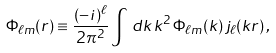<formula> <loc_0><loc_0><loc_500><loc_500>\Phi _ { \ell m } ( r ) \equiv \frac { ( - i ) ^ { \ell } } { 2 \pi ^ { 2 } } \int \, d k \, k ^ { 2 } \, \Phi _ { \ell m } ( k ) \, j _ { \ell } ( k r ) \, ,</formula> 